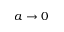<formula> <loc_0><loc_0><loc_500><loc_500>a \rightarrow 0</formula> 